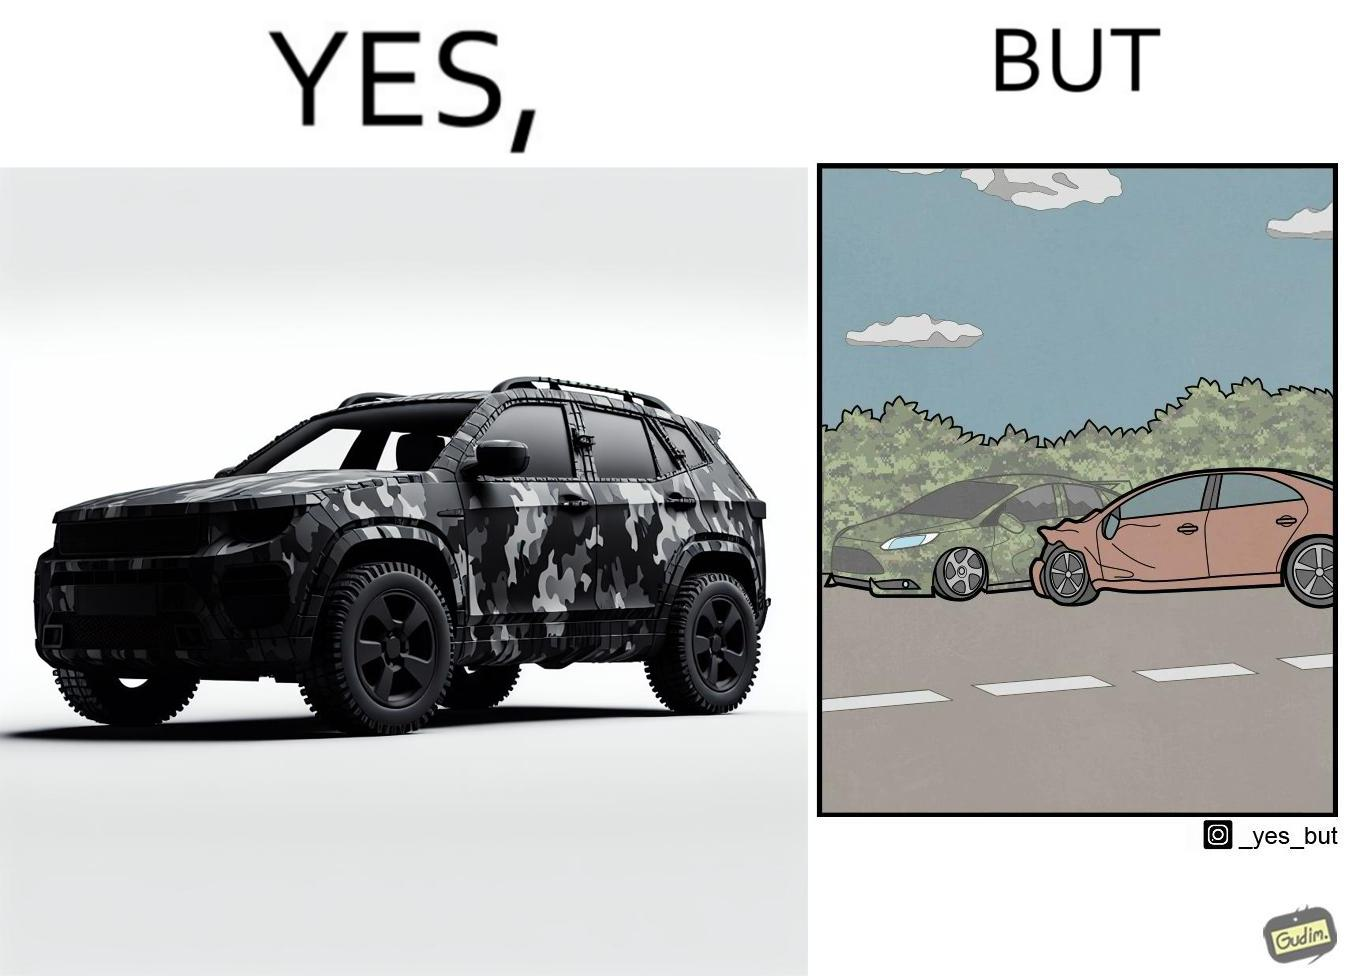Explain the humor or irony in this image. The image is ironic, because in the left image a car is painted in camouflage color but in the right image the same car is getting involved in accident to due to its color as other drivers face difficulty in recognizing the colors 